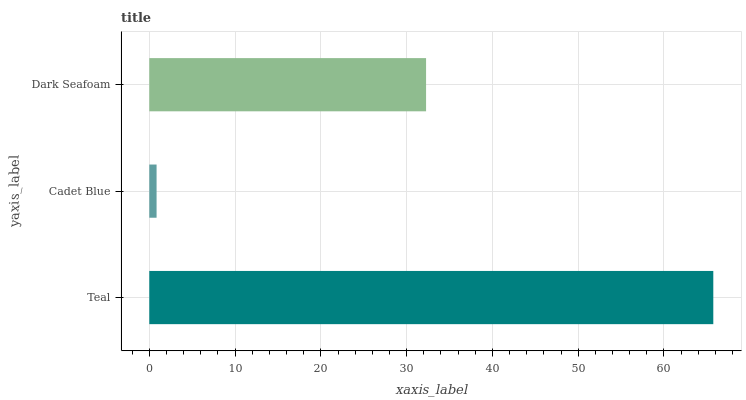Is Cadet Blue the minimum?
Answer yes or no. Yes. Is Teal the maximum?
Answer yes or no. Yes. Is Dark Seafoam the minimum?
Answer yes or no. No. Is Dark Seafoam the maximum?
Answer yes or no. No. Is Dark Seafoam greater than Cadet Blue?
Answer yes or no. Yes. Is Cadet Blue less than Dark Seafoam?
Answer yes or no. Yes. Is Cadet Blue greater than Dark Seafoam?
Answer yes or no. No. Is Dark Seafoam less than Cadet Blue?
Answer yes or no. No. Is Dark Seafoam the high median?
Answer yes or no. Yes. Is Dark Seafoam the low median?
Answer yes or no. Yes. Is Teal the high median?
Answer yes or no. No. Is Teal the low median?
Answer yes or no. No. 